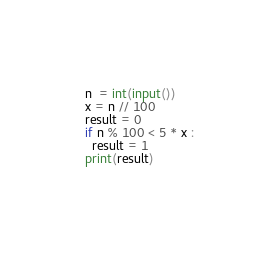<code> <loc_0><loc_0><loc_500><loc_500><_Python_>n  = int(input())
x = n // 100
result = 0
if n % 100 < 5 * x :
  result = 1
print(result)
  </code> 